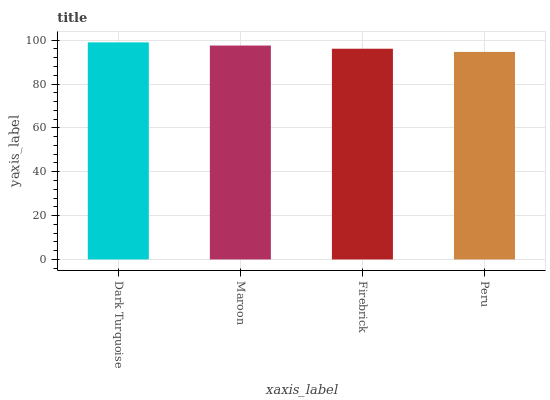Is Peru the minimum?
Answer yes or no. Yes. Is Dark Turquoise the maximum?
Answer yes or no. Yes. Is Maroon the minimum?
Answer yes or no. No. Is Maroon the maximum?
Answer yes or no. No. Is Dark Turquoise greater than Maroon?
Answer yes or no. Yes. Is Maroon less than Dark Turquoise?
Answer yes or no. Yes. Is Maroon greater than Dark Turquoise?
Answer yes or no. No. Is Dark Turquoise less than Maroon?
Answer yes or no. No. Is Maroon the high median?
Answer yes or no. Yes. Is Firebrick the low median?
Answer yes or no. Yes. Is Peru the high median?
Answer yes or no. No. Is Peru the low median?
Answer yes or no. No. 